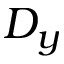Convert formula to latex. <formula><loc_0><loc_0><loc_500><loc_500>D _ { y }</formula> 